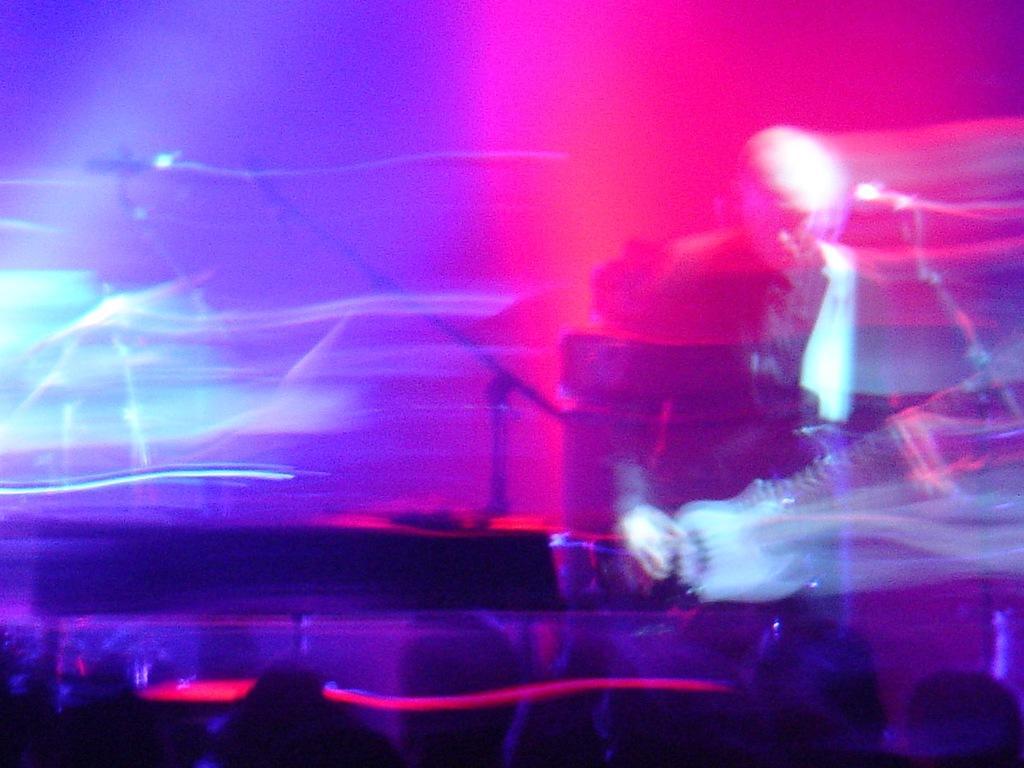In one or two sentences, can you explain what this image depicts? In the picture we can see a image of a man playing a musical instrument and near the microphone and behind him we can see some musical instruments and the picture is with light focus. 